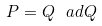<formula> <loc_0><loc_0><loc_500><loc_500>P = Q \ a d Q</formula> 